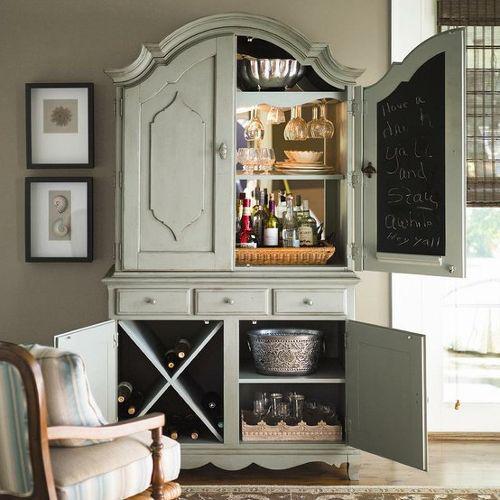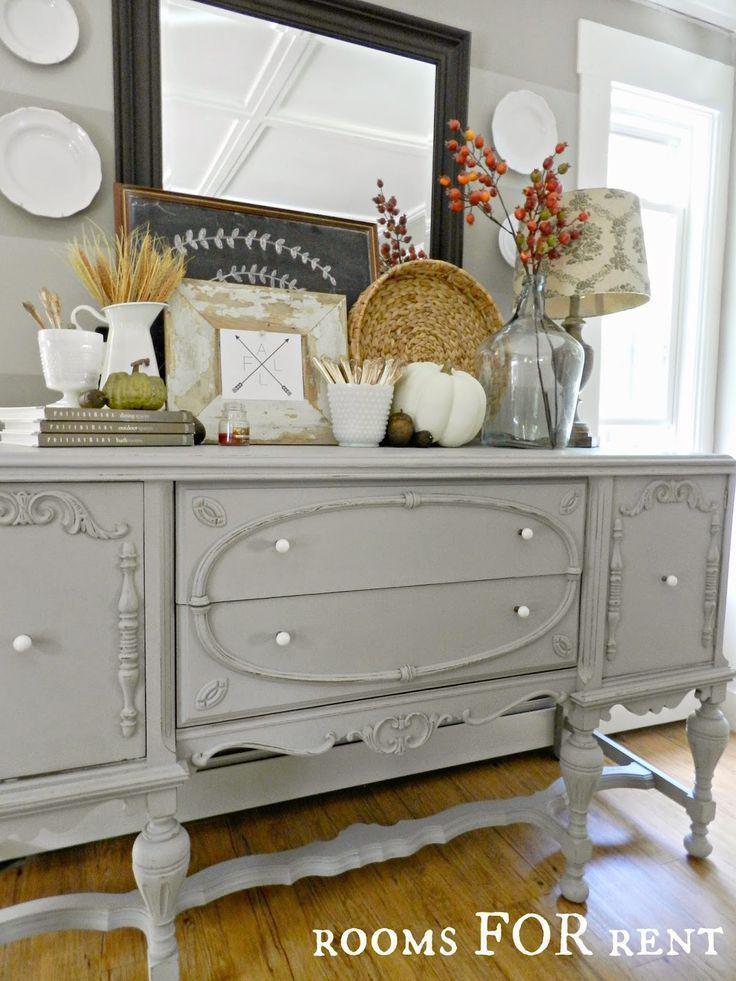The first image is the image on the left, the second image is the image on the right. Analyze the images presented: Is the assertion "A wooden painted hutch has a bottom door open that shows an X shaped space for storing bottles of wine, and glasses hanging upside down in the upper section." valid? Answer yes or no. Yes. The first image is the image on the left, the second image is the image on the right. Evaluate the accuracy of this statement regarding the images: "A brown cabinet is used for storage in the image on the right.". Is it true? Answer yes or no. No. 